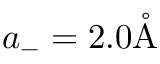Convert formula to latex. <formula><loc_0><loc_0><loc_500><loc_500>a _ { - } = 2 . 0 \mathring { A }</formula> 